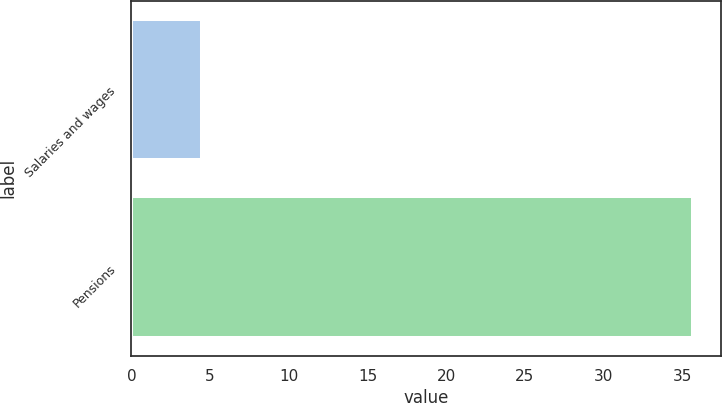Convert chart. <chart><loc_0><loc_0><loc_500><loc_500><bar_chart><fcel>Salaries and wages<fcel>Pensions<nl><fcel>4.5<fcel>35.7<nl></chart> 